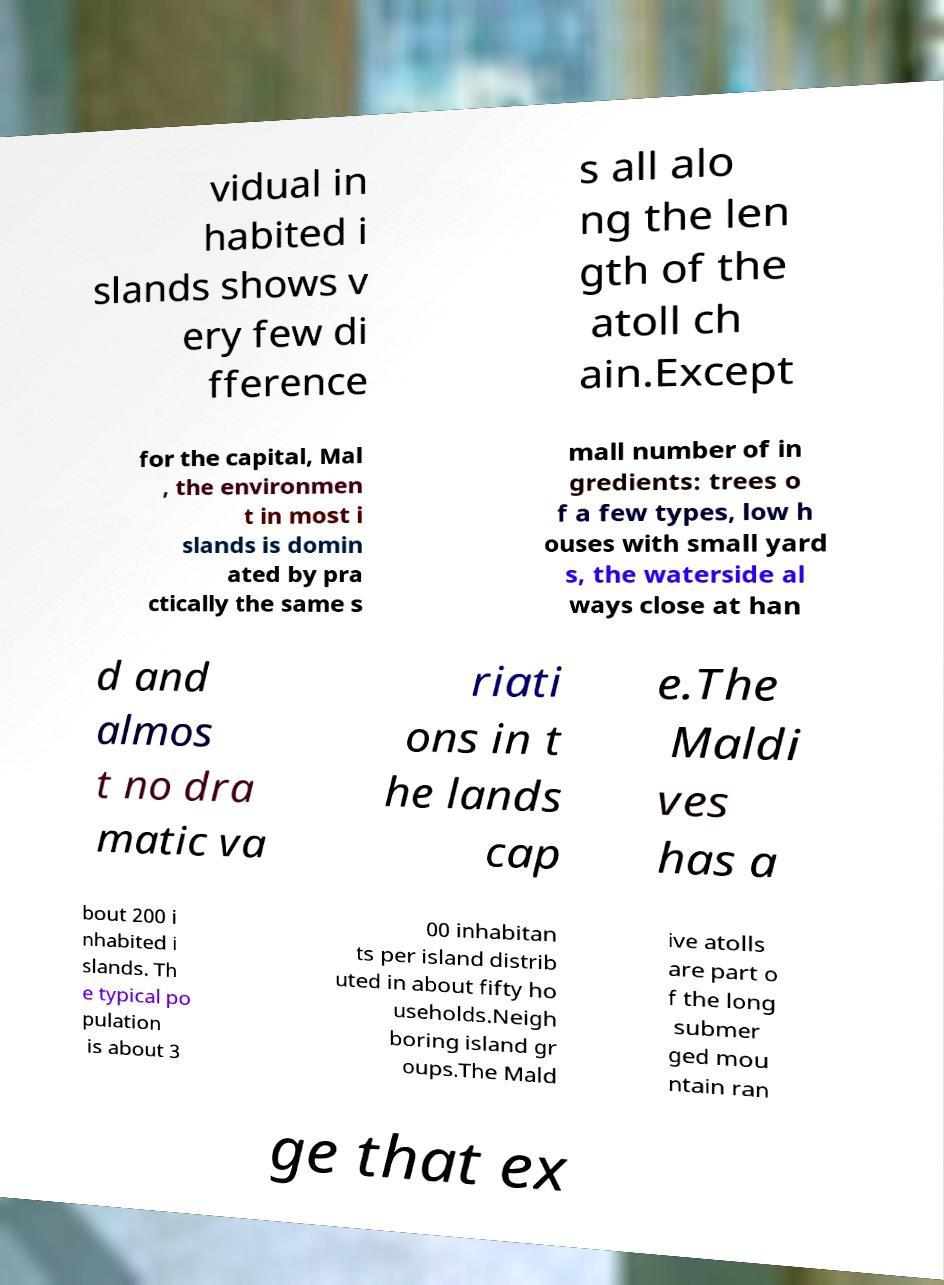Please identify and transcribe the text found in this image. vidual in habited i slands shows v ery few di fference s all alo ng the len gth of the atoll ch ain.Except for the capital, Mal , the environmen t in most i slands is domin ated by pra ctically the same s mall number of in gredients: trees o f a few types, low h ouses with small yard s, the waterside al ways close at han d and almos t no dra matic va riati ons in t he lands cap e.The Maldi ves has a bout 200 i nhabited i slands. Th e typical po pulation is about 3 00 inhabitan ts per island distrib uted in about fifty ho useholds.Neigh boring island gr oups.The Mald ive atolls are part o f the long submer ged mou ntain ran ge that ex 